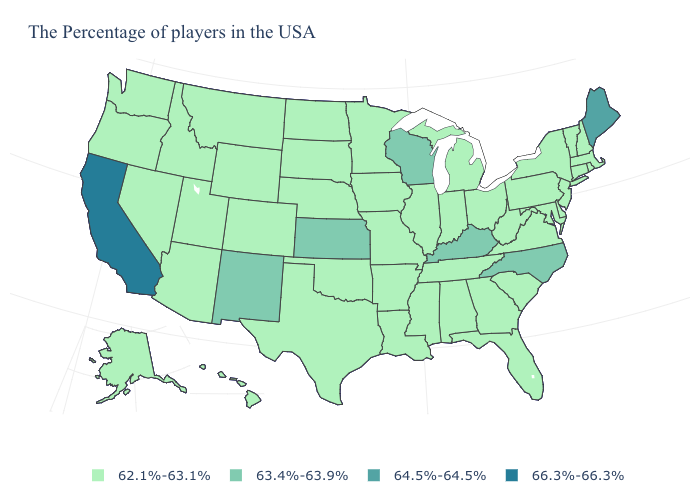What is the value of Hawaii?
Give a very brief answer. 62.1%-63.1%. What is the value of Ohio?
Short answer required. 62.1%-63.1%. Does New Hampshire have the same value as Kansas?
Write a very short answer. No. What is the lowest value in states that border South Dakota?
Give a very brief answer. 62.1%-63.1%. Does Texas have the same value as Nebraska?
Answer briefly. Yes. What is the highest value in the USA?
Short answer required. 66.3%-66.3%. Does Ohio have the lowest value in the MidWest?
Keep it brief. Yes. Name the states that have a value in the range 64.5%-64.5%?
Quick response, please. Maine. Name the states that have a value in the range 66.3%-66.3%?
Short answer required. California. What is the lowest value in states that border Michigan?
Quick response, please. 62.1%-63.1%. What is the lowest value in states that border Kansas?
Write a very short answer. 62.1%-63.1%. Name the states that have a value in the range 62.1%-63.1%?
Keep it brief. Massachusetts, Rhode Island, New Hampshire, Vermont, Connecticut, New York, New Jersey, Delaware, Maryland, Pennsylvania, Virginia, South Carolina, West Virginia, Ohio, Florida, Georgia, Michigan, Indiana, Alabama, Tennessee, Illinois, Mississippi, Louisiana, Missouri, Arkansas, Minnesota, Iowa, Nebraska, Oklahoma, Texas, South Dakota, North Dakota, Wyoming, Colorado, Utah, Montana, Arizona, Idaho, Nevada, Washington, Oregon, Alaska, Hawaii. Which states have the highest value in the USA?
Give a very brief answer. California. What is the highest value in the South ?
Quick response, please. 63.4%-63.9%. What is the value of Arizona?
Write a very short answer. 62.1%-63.1%. 